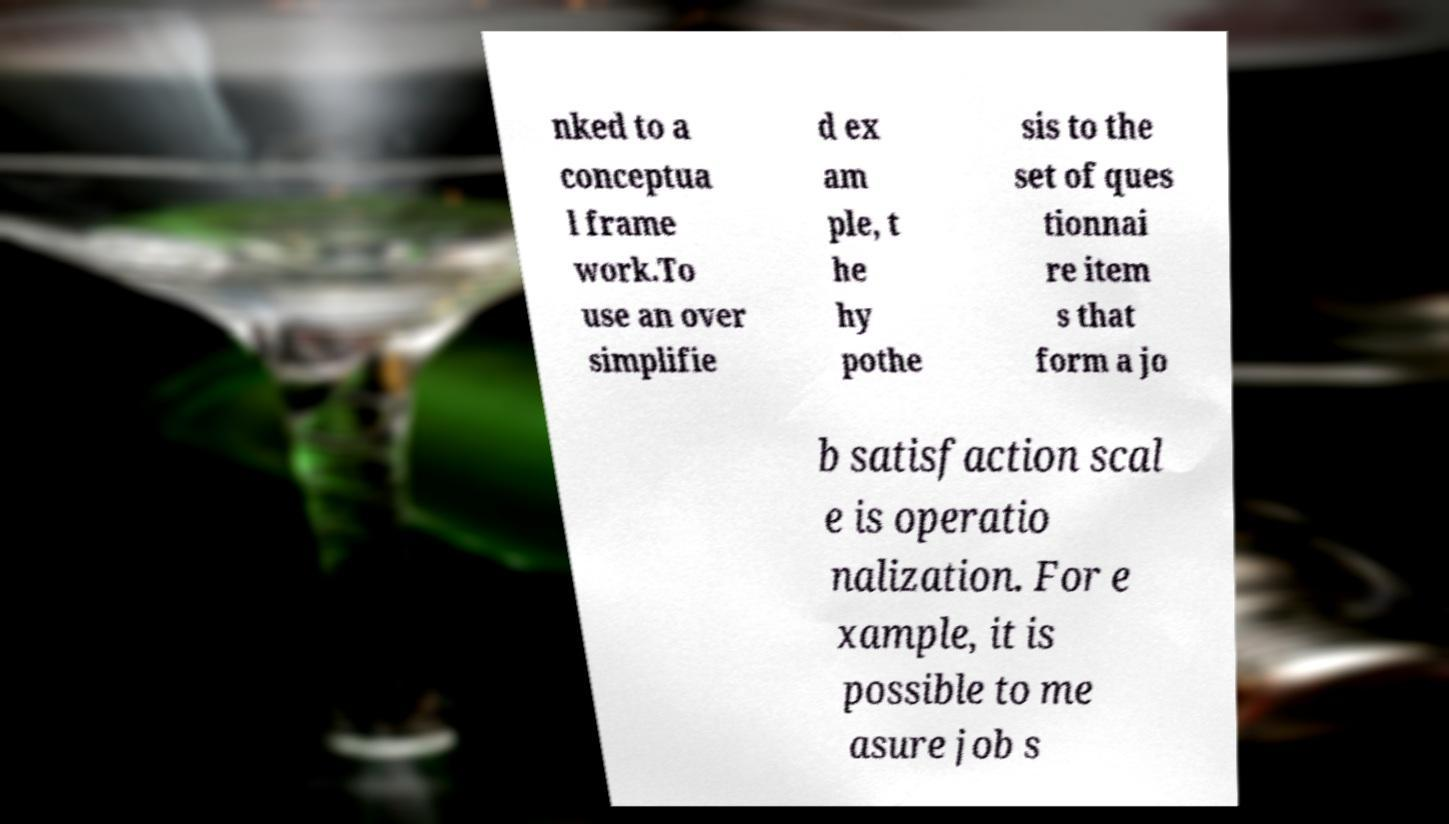Please identify and transcribe the text found in this image. nked to a conceptua l frame work.To use an over simplifie d ex am ple, t he hy pothe sis to the set of ques tionnai re item s that form a jo b satisfaction scal e is operatio nalization. For e xample, it is possible to me asure job s 